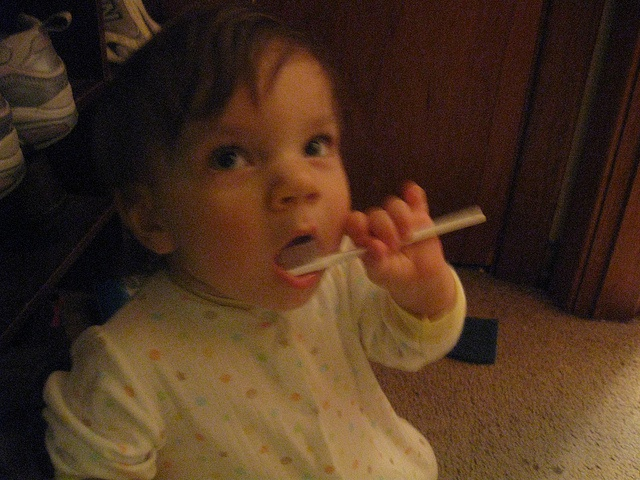Describe the objects in this image and their specific colors. I can see people in black, maroon, olive, and brown tones and toothbrush in black, gray, maroon, and olive tones in this image. 